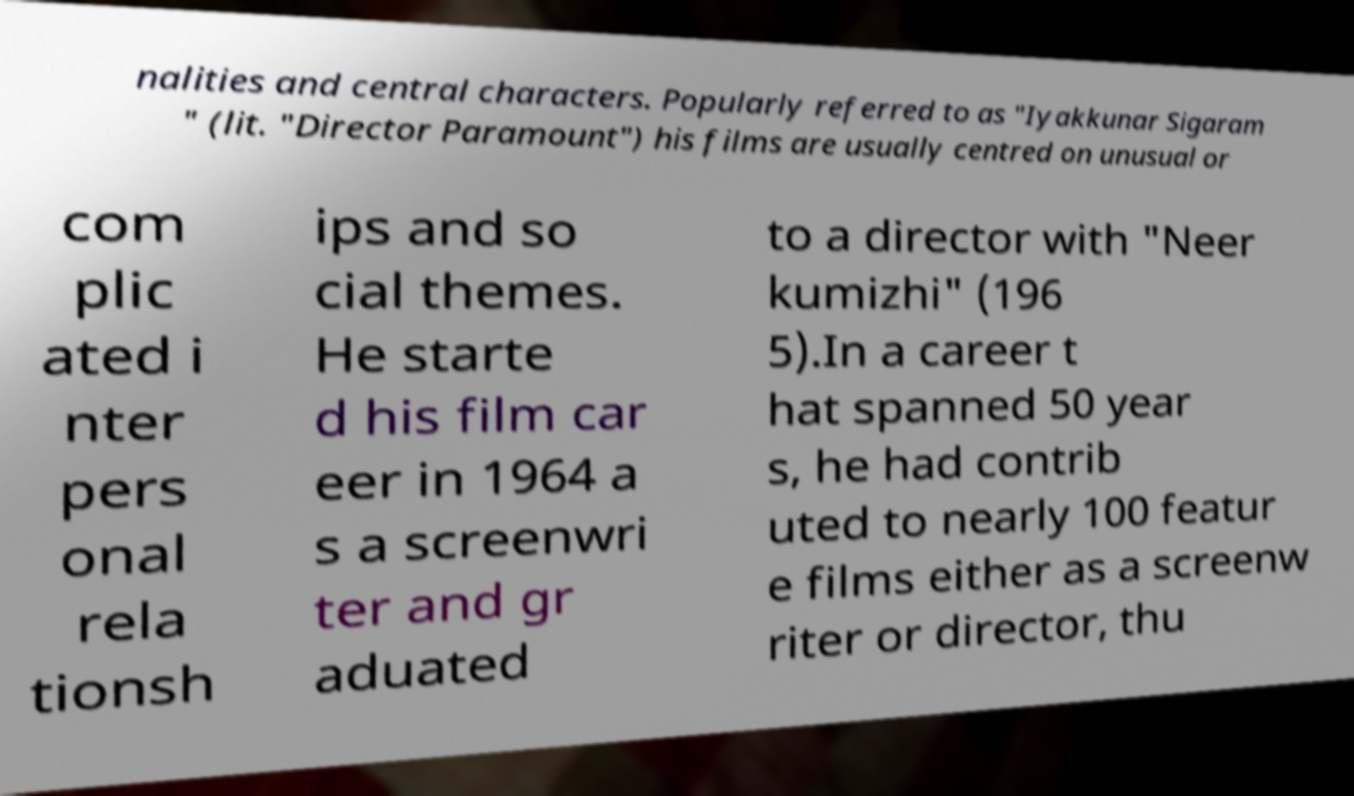Can you read and provide the text displayed in the image?This photo seems to have some interesting text. Can you extract and type it out for me? nalities and central characters. Popularly referred to as "Iyakkunar Sigaram " (lit. "Director Paramount") his films are usually centred on unusual or com plic ated i nter pers onal rela tionsh ips and so cial themes. He starte d his film car eer in 1964 a s a screenwri ter and gr aduated to a director with "Neer kumizhi" (196 5).In a career t hat spanned 50 year s, he had contrib uted to nearly 100 featur e films either as a screenw riter or director, thu 